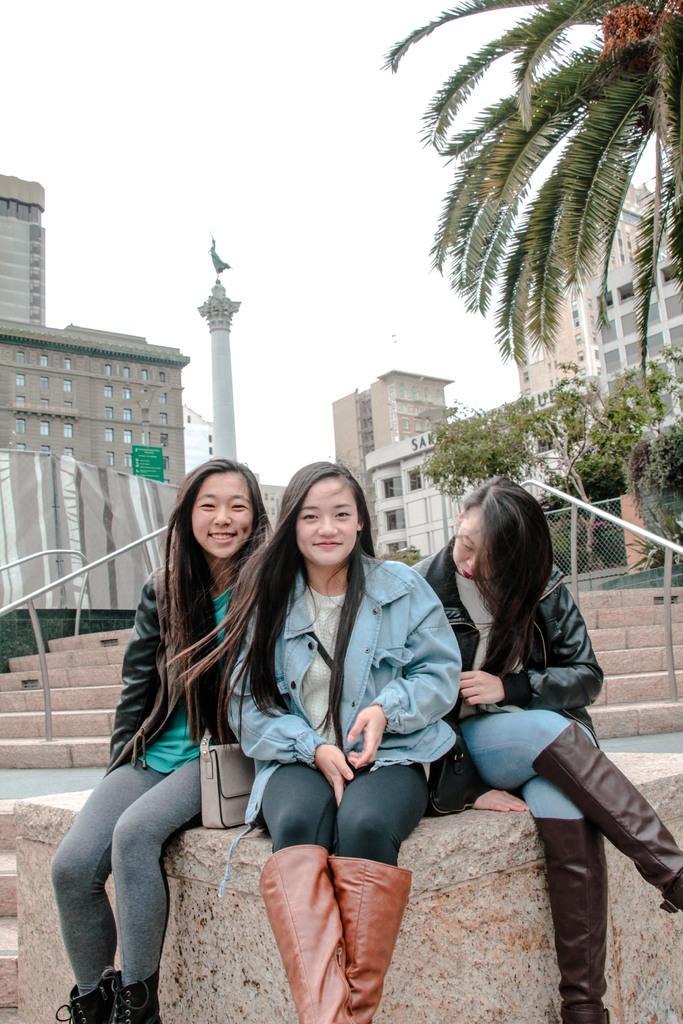Describe this image in one or two sentences. In this image I can see three women wearing jackets and boots are sitting on the concrete wall. In the background I can see few stairs, the railing, the metal fence, few trees and the cloth. In the background I can see few buildings, a green colored board and the sky. 